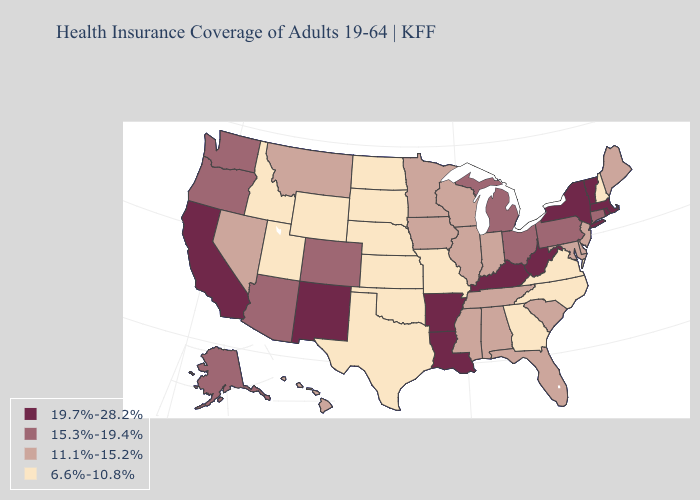Which states have the highest value in the USA?
Be succinct. Arkansas, California, Kentucky, Louisiana, Massachusetts, New Mexico, New York, Rhode Island, Vermont, West Virginia. What is the value of Tennessee?
Keep it brief. 11.1%-15.2%. What is the highest value in the South ?
Write a very short answer. 19.7%-28.2%. What is the value of Arkansas?
Answer briefly. 19.7%-28.2%. Name the states that have a value in the range 19.7%-28.2%?
Be succinct. Arkansas, California, Kentucky, Louisiana, Massachusetts, New Mexico, New York, Rhode Island, Vermont, West Virginia. Does Texas have the lowest value in the USA?
Be succinct. Yes. Among the states that border Massachusetts , does Rhode Island have the highest value?
Short answer required. Yes. Name the states that have a value in the range 15.3%-19.4%?
Quick response, please. Alaska, Arizona, Colorado, Connecticut, Michigan, Ohio, Oregon, Pennsylvania, Washington. Among the states that border New York , does Pennsylvania have the highest value?
Keep it brief. No. What is the lowest value in states that border New Jersey?
Write a very short answer. 11.1%-15.2%. Does Rhode Island have the highest value in the Northeast?
Give a very brief answer. Yes. What is the highest value in the USA?
Keep it brief. 19.7%-28.2%. Does Arkansas have the highest value in the South?
Keep it brief. Yes. What is the lowest value in the MidWest?
Give a very brief answer. 6.6%-10.8%. 